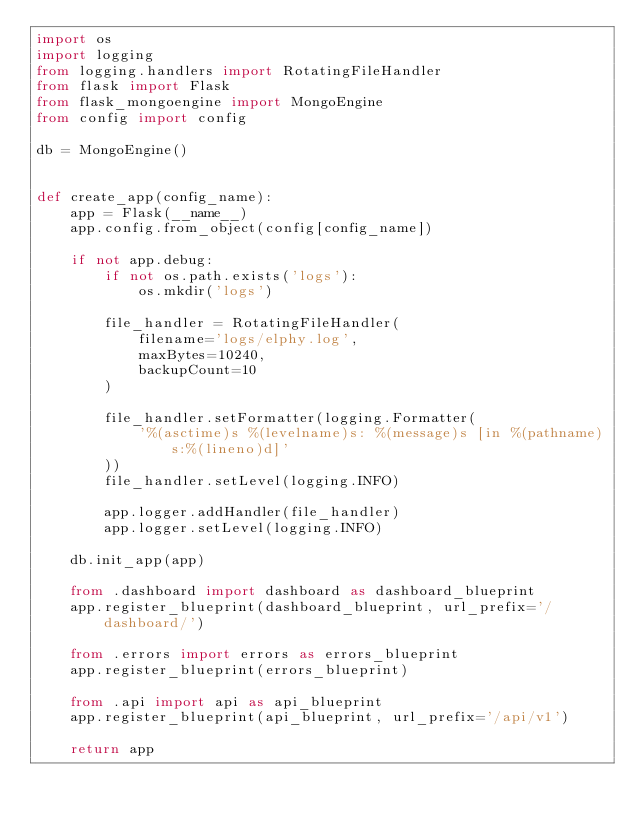Convert code to text. <code><loc_0><loc_0><loc_500><loc_500><_Python_>import os
import logging
from logging.handlers import RotatingFileHandler
from flask import Flask
from flask_mongoengine import MongoEngine
from config import config

db = MongoEngine()


def create_app(config_name):
    app = Flask(__name__)
    app.config.from_object(config[config_name])

    if not app.debug:
        if not os.path.exists('logs'):
            os.mkdir('logs')

        file_handler = RotatingFileHandler(
            filename='logs/elphy.log',
            maxBytes=10240,
            backupCount=10
        )

        file_handler.setFormatter(logging.Formatter(
            '%(asctime)s %(levelname)s: %(message)s [in %(pathname)s:%(lineno)d]'
        ))
        file_handler.setLevel(logging.INFO)

        app.logger.addHandler(file_handler)
        app.logger.setLevel(logging.INFO)

    db.init_app(app)

    from .dashboard import dashboard as dashboard_blueprint
    app.register_blueprint(dashboard_blueprint, url_prefix='/dashboard/')

    from .errors import errors as errors_blueprint
    app.register_blueprint(errors_blueprint)

    from .api import api as api_blueprint
    app.register_blueprint(api_blueprint, url_prefix='/api/v1')

    return app
</code> 